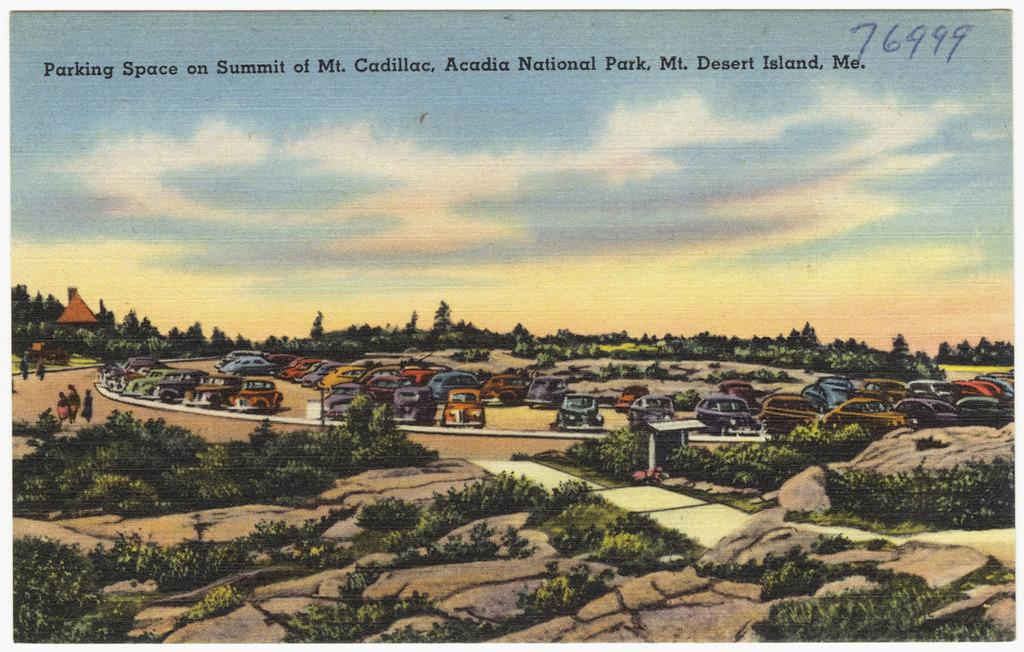<image>
Provide a brief description of the given image. A card shows the parking spaces at a summit. 